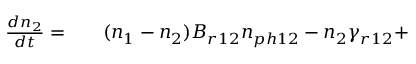<formula> <loc_0><loc_0><loc_500><loc_500>\begin{array} { r l r } { \frac { d n _ { 2 } } { d t } = } & { ( n _ { 1 } - n _ { 2 } ) B _ { r 1 2 } n _ { p h 1 2 } - n _ { 2 } \gamma _ { r 1 2 } + } \end{array}</formula> 